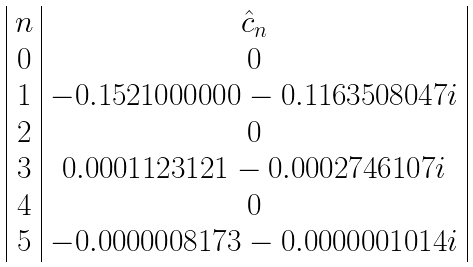Convert formula to latex. <formula><loc_0><loc_0><loc_500><loc_500>\begin{array} { | c | c | } n & \hat { c } _ { n } \\ 0 & 0 \\ 1 & - 0 . 1 5 2 1 0 0 0 0 0 0 - 0 . 1 1 6 3 5 0 8 0 4 7 i \\ 2 & 0 \\ 3 & 0 . 0 0 0 1 1 2 3 1 2 1 - 0 . 0 0 0 2 7 4 6 1 0 7 i \\ 4 & 0 \\ 5 & - 0 . 0 0 0 0 0 0 8 1 7 3 - 0 . 0 0 0 0 0 0 1 0 1 4 i \\ \end{array}</formula> 